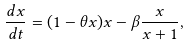<formula> <loc_0><loc_0><loc_500><loc_500>\frac { d x } { d t } = ( 1 - \theta x ) x - \beta \frac { x } { x + 1 } ,</formula> 